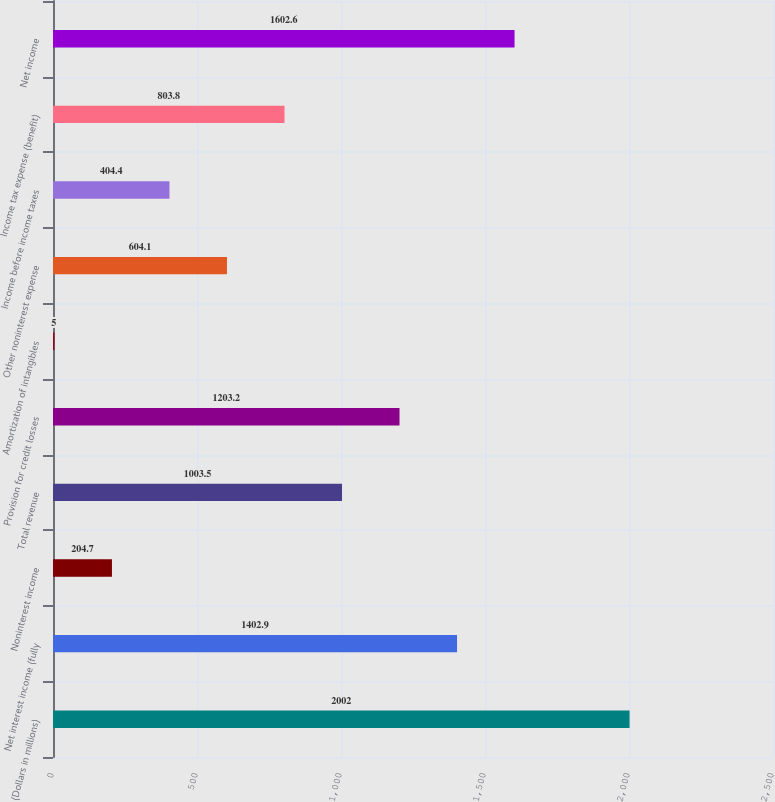<chart> <loc_0><loc_0><loc_500><loc_500><bar_chart><fcel>(Dollars in millions)<fcel>Net interest income (fully<fcel>Noninterest income<fcel>Total revenue<fcel>Provision for credit losses<fcel>Amortization of intangibles<fcel>Other noninterest expense<fcel>Income before income taxes<fcel>Income tax expense (benefit)<fcel>Net income<nl><fcel>2002<fcel>1402.9<fcel>204.7<fcel>1003.5<fcel>1203.2<fcel>5<fcel>604.1<fcel>404.4<fcel>803.8<fcel>1602.6<nl></chart> 